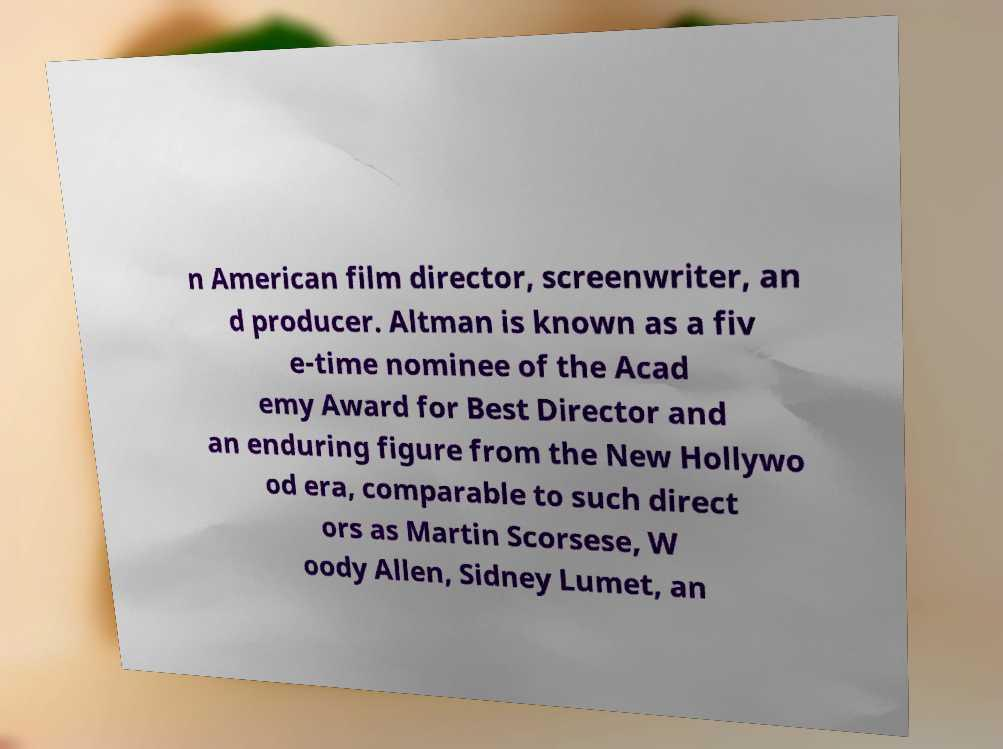Could you extract and type out the text from this image? n American film director, screenwriter, an d producer. Altman is known as a fiv e-time nominee of the Acad emy Award for Best Director and an enduring figure from the New Hollywo od era, comparable to such direct ors as Martin Scorsese, W oody Allen, Sidney Lumet, an 